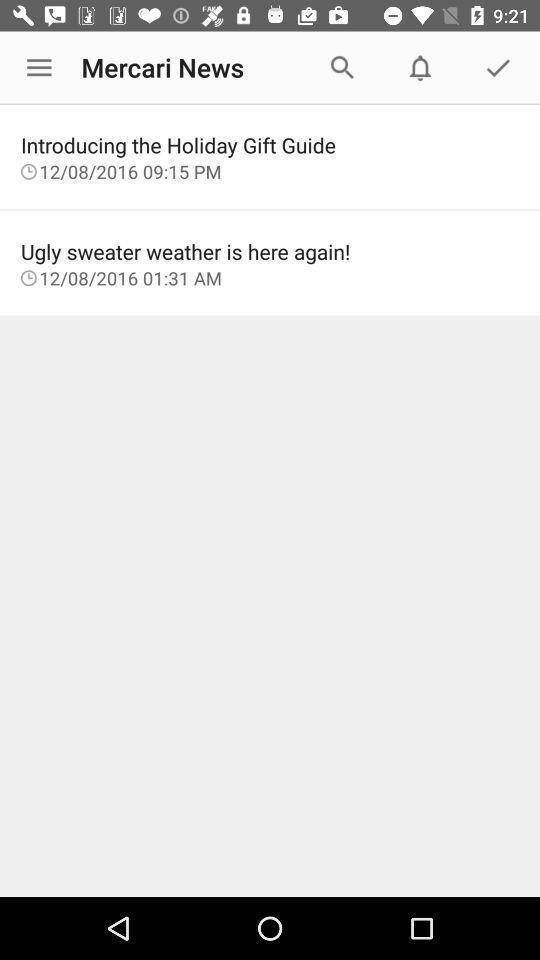Please provide a description for this image. Screen displaying the news options. 